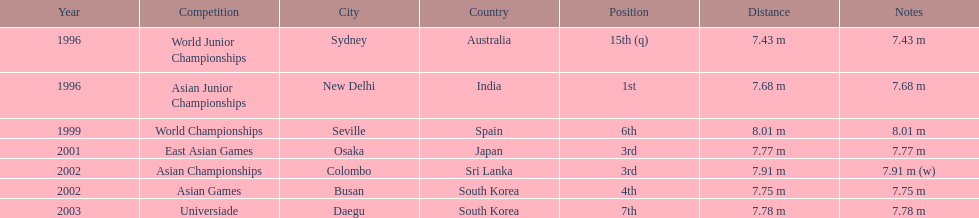How many total competitions were in south korea? 2. 